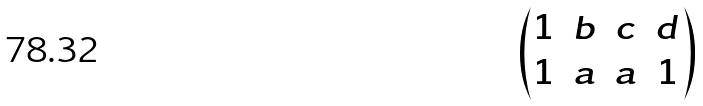Convert formula to latex. <formula><loc_0><loc_0><loc_500><loc_500>\begin{pmatrix} 1 & b & c & d \\ 1 & a & a & 1 \end{pmatrix}</formula> 